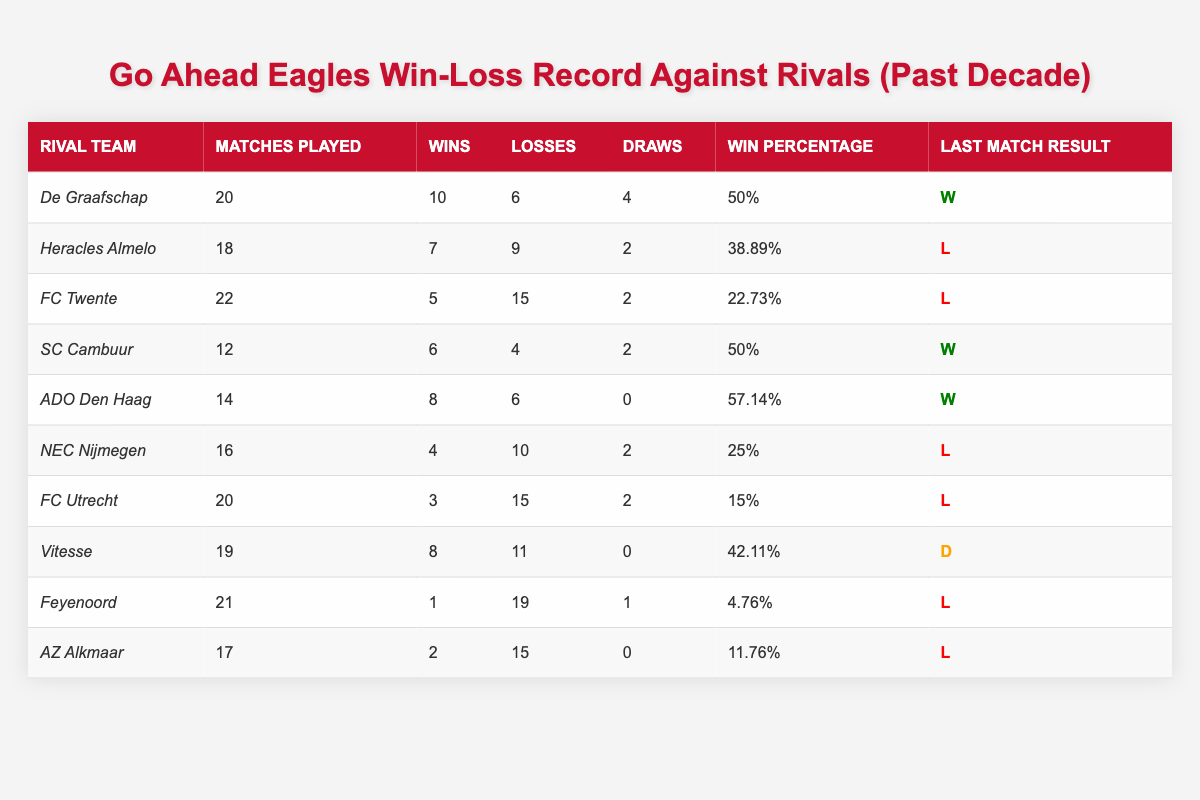What is the win percentage of Go Ahead Eagles against ADO Den Haag? According to the table, the win percentage for ADO Den Haag is listed as 57.14%.
Answer: 57.14% How many matches has Go Ahead Eagles played against FC Twente? The table indicates that Go Ahead Eagles has played 22 matches against FC Twente.
Answer: 22 Which rival team has the highest number of losses against Go Ahead Eagles? By examining the table, FC Twente has the highest number of losses at 15.
Answer: FC Twente What is the total number of wins for Go Ahead Eagles against all rival teams listed? To find the total wins, we add the wins against each team: 10 + 7 + 5 + 6 + 8 + 4 + 3 + 8 + 1 + 2 = 54.
Answer: 54 How does the win percentage of Go Ahead Eagles against De Graafschap compare to that against Heracles Almelo? The win percentage against De Graafschap is 50%, while against Heracles Almelo it is 38.89%. De Graafschap has a higher win percentage.
Answer: De Graafschap is higher What is the record of Go Ahead Eagles in terms of wins and losses against FC Utrecht? The record against FC Utrecht shows 3 wins and 15 losses in 20 matches played.
Answer: 3 wins, 15 losses Is it true that Go Ahead Eagles has more wins than losses against SC Cambuur? The table shows 6 wins and 4 losses against SC Cambuur, which means it is true that they have more wins.
Answer: Yes What is the average win percentage of Go Ahead Eagles against these rival teams? To calculate, sum all win percentages: (50 + 38.89 + 22.73 + 50 + 57.14 + 25 + 15 + 42.11 + 4.76 + 11.76) / 10 gives an average of approximately 31.34%.
Answer: 31.34% Which team did Go Ahead Eagles recently win against, based on the last match result? The table highlights two teams, De Graafschap and ADO Den Haag, where the last match result is a win.
Answer: De Graafschap, ADO Den Haag If Go Ahead Eagles played 18 matches against Heracles Almelo, how many more losses did they have compared to wins? They recorded 7 wins and 9 losses against Heracles Almelo. This is 2 more losses than wins (9 - 7 = 2).
Answer: 2 losses more 